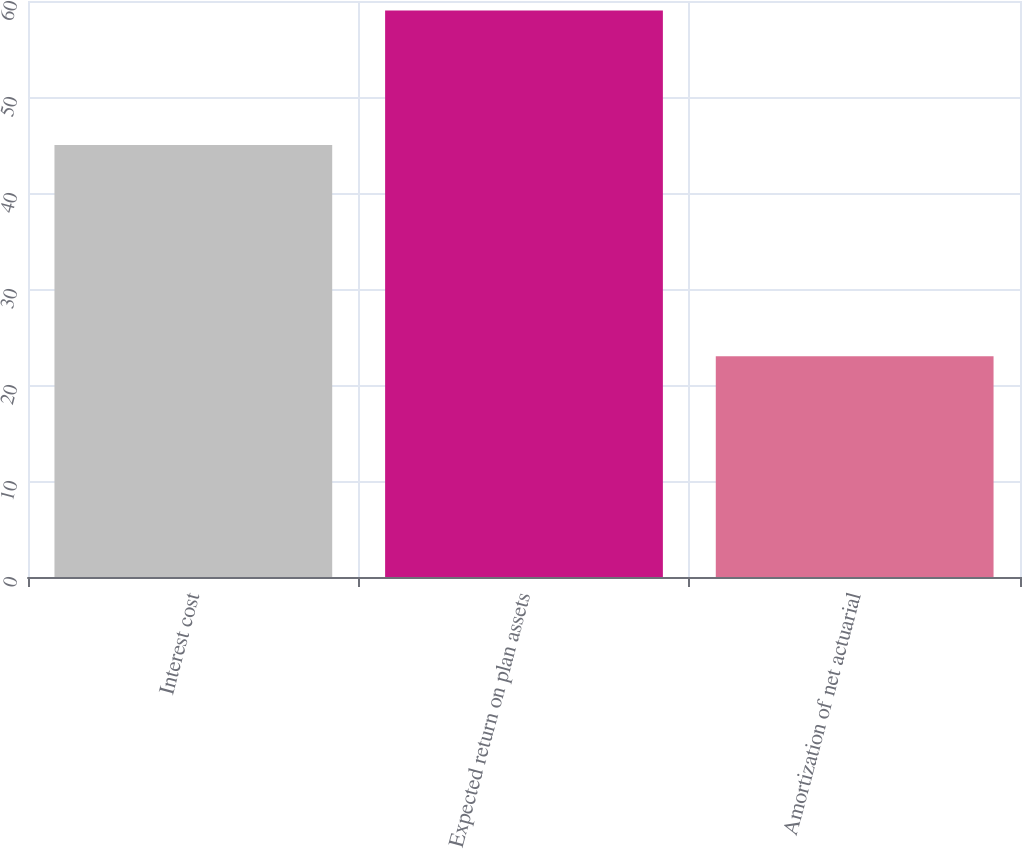Convert chart to OTSL. <chart><loc_0><loc_0><loc_500><loc_500><bar_chart><fcel>Interest cost<fcel>Expected return on plan assets<fcel>Amortization of net actuarial<nl><fcel>45<fcel>59<fcel>23<nl></chart> 